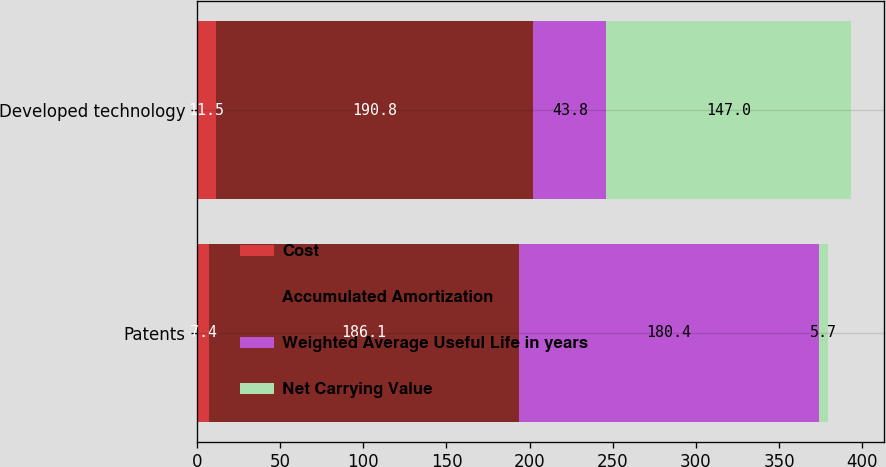Convert chart. <chart><loc_0><loc_0><loc_500><loc_500><stacked_bar_chart><ecel><fcel>Patents<fcel>Developed technology<nl><fcel>Cost<fcel>7.4<fcel>11.5<nl><fcel>Accumulated Amortization<fcel>186.1<fcel>190.8<nl><fcel>Weighted Average Useful Life in years<fcel>180.4<fcel>43.8<nl><fcel>Net Carrying Value<fcel>5.7<fcel>147<nl></chart> 